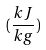Convert formula to latex. <formula><loc_0><loc_0><loc_500><loc_500>( \frac { k J } { k g } )</formula> 